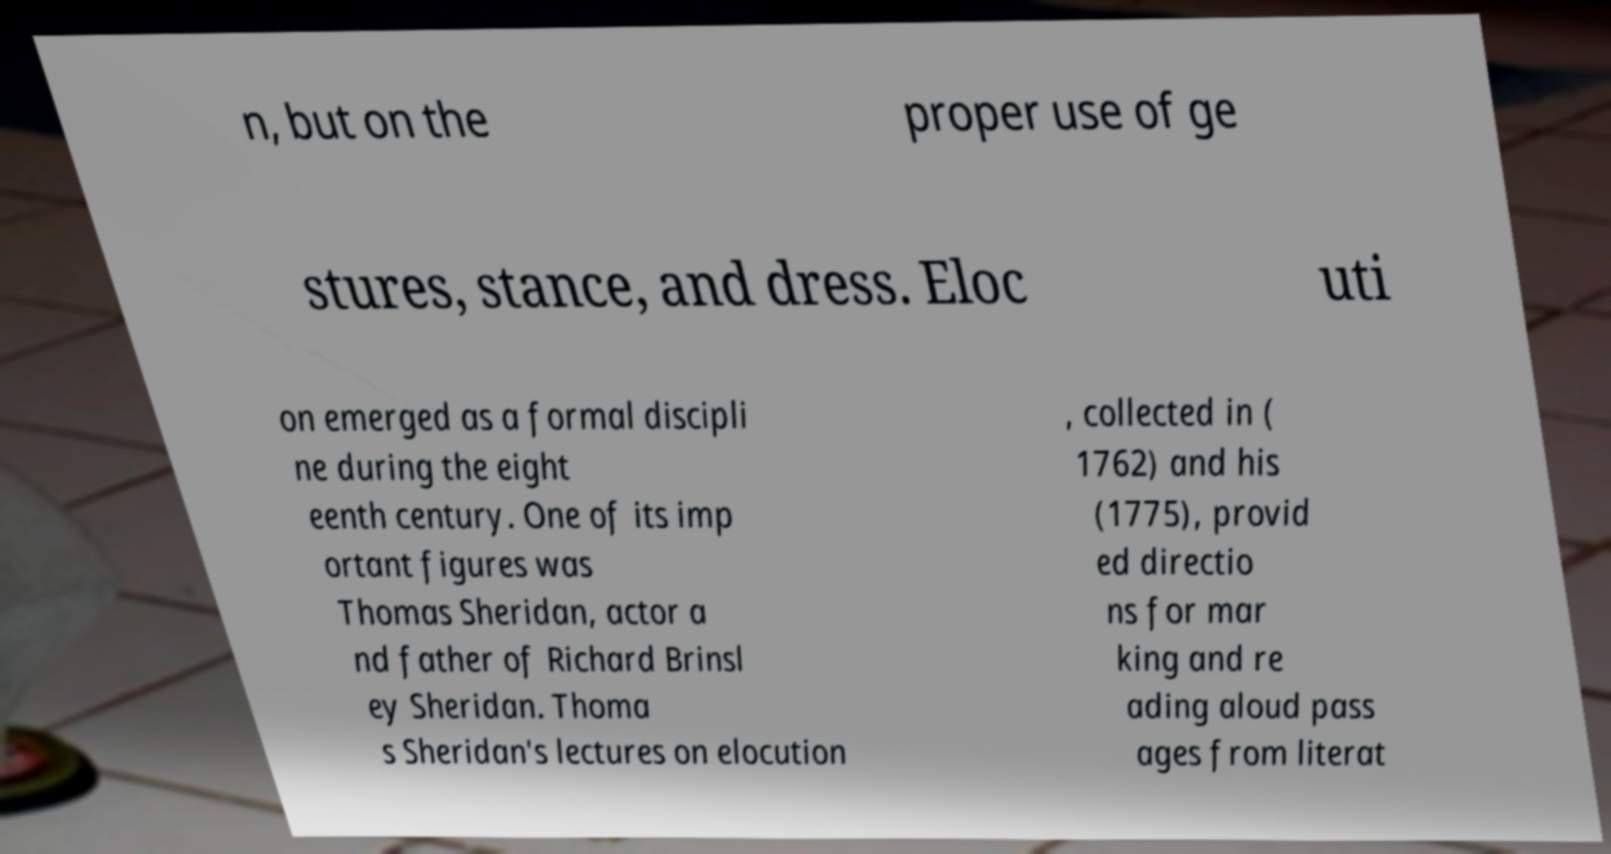Could you extract and type out the text from this image? n, but on the proper use of ge stures, stance, and dress. Eloc uti on emerged as a formal discipli ne during the eight eenth century. One of its imp ortant figures was Thomas Sheridan, actor a nd father of Richard Brinsl ey Sheridan. Thoma s Sheridan's lectures on elocution , collected in ( 1762) and his (1775), provid ed directio ns for mar king and re ading aloud pass ages from literat 